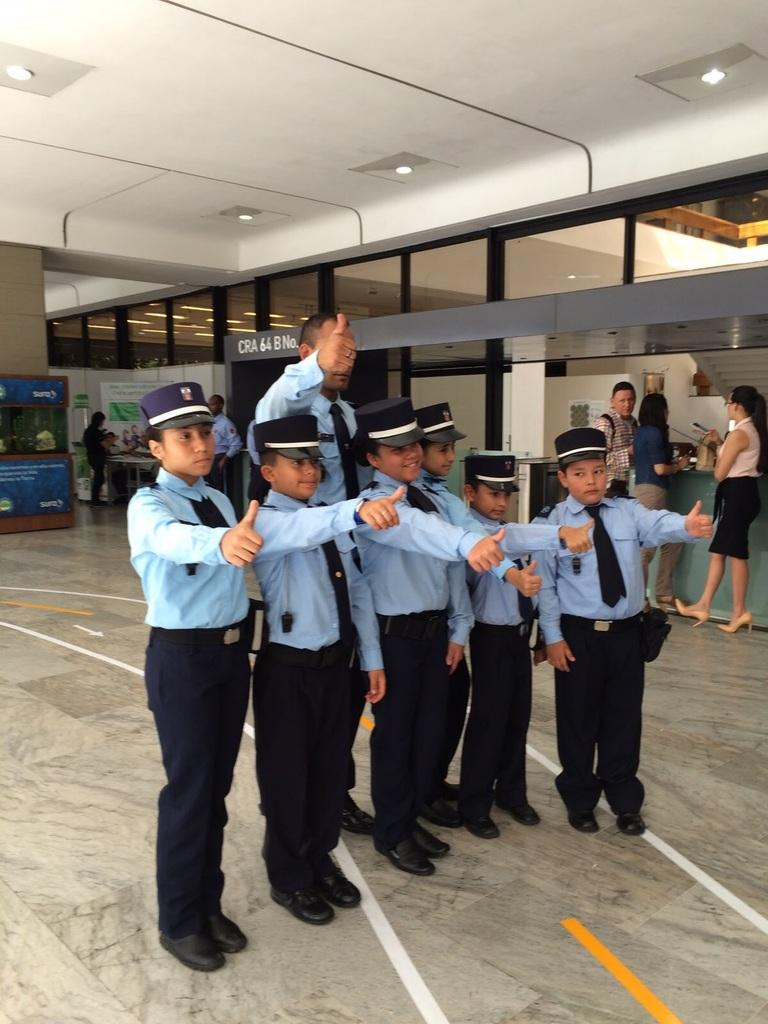How many people are in the image? There are people in the image, but the exact number is not specified. What can be observed about the attire of some people in the image? Some people in the image are in a dress code. What is visible beneath the people in the image? The floor is visible in the image. What type of establishment can be identified in the image? There are stores in the image. What is written or displayed on a board in the image? There is text on a board in the image. What type of decoration or signage is present in the image? Banners are present in the image. What type of structure is visible in the image? There is a wall in the image. What is visible above the people in the image? The roof with lights is visible in the image. What is the tendency of the zebra in the image? There is no zebra present in the image, so it is not possible to determine its tendency. What type of wine is being served at the event in the image? There is no mention of wine or an event in the image, so it is not possible to determine what type of wine might be served. 